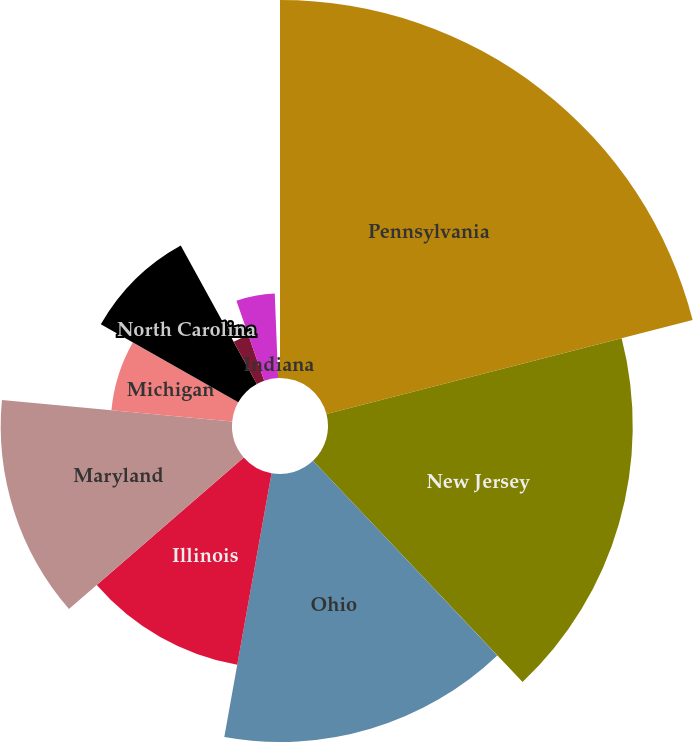<chart> <loc_0><loc_0><loc_500><loc_500><pie_chart><fcel>Pennsylvania<fcel>New Jersey<fcel>Ohio<fcel>Illinois<fcel>Maryland<fcel>Michigan<fcel>North Carolina<fcel>Florida<fcel>Kentucky<fcel>Indiana<nl><fcel>21.0%<fcel>16.93%<fcel>14.89%<fcel>10.81%<fcel>12.85%<fcel>6.74%<fcel>8.78%<fcel>2.67%<fcel>4.7%<fcel>0.63%<nl></chart> 